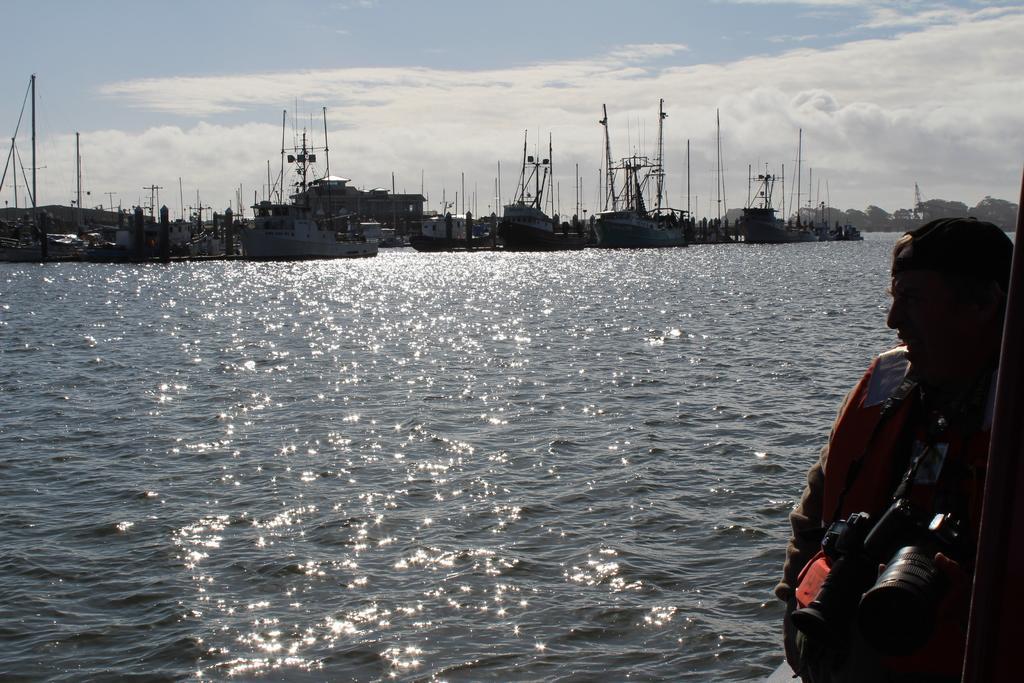How would you summarize this image in a sentence or two? This picture is clicked outside the city. On the right there is a person holding some objects and standing. In the center there is a water body. In the background we can see the sky which is full of clouds and we can see the ships and some boats and we can see the trees and the poles. 